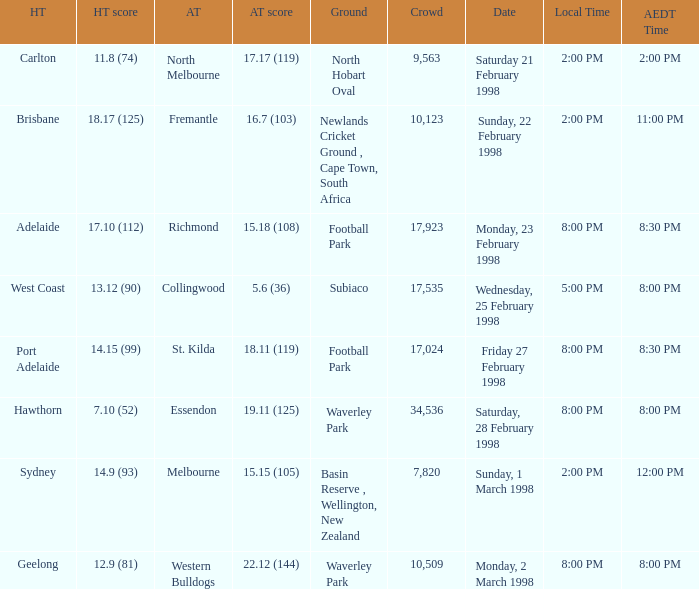Name the Away team which has a Ground of waverley park, and a Home team of hawthorn? Essendon. 